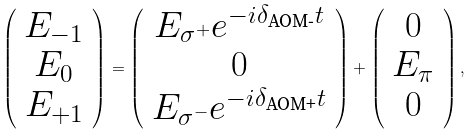<formula> <loc_0><loc_0><loc_500><loc_500>\left ( \begin{array} { c } E _ { - 1 } \\ E _ { 0 } \\ E _ { + 1 } \\ \end{array} \right ) = \left ( \begin{array} { c } E _ { \sigma ^ { + } } e ^ { - i \delta _ { \text {AOM-} } t } \\ 0 \\ E _ { \sigma ^ { - } } e ^ { - i \delta _ { \text {AOM+} } t } \\ \end{array} \right ) + \left ( \begin{array} { c } 0 \\ E _ { \pi } \\ 0 \\ \end{array} \right ) ,</formula> 